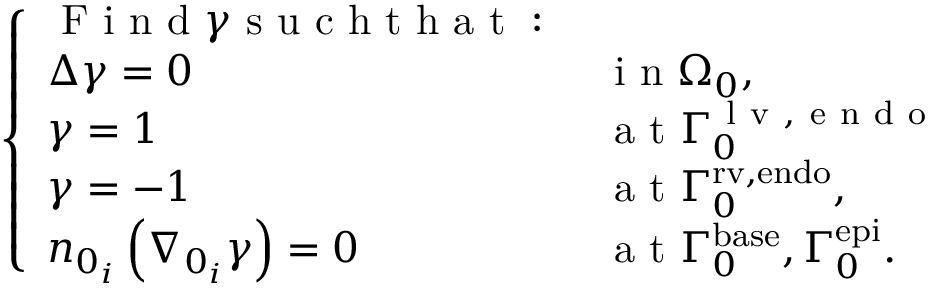Convert formula to latex. <formula><loc_0><loc_0><loc_500><loc_500>\left \{ \begin{array} { l l } { F i n d \gamma s u c h t h a t \colon } \\ { \Delta \gamma = 0 } & { i n { \Omega } _ { 0 } , } \\ { \gamma = 1 } & { a t { \Gamma } _ { 0 } ^ { l v , e n d o } } \\ { \gamma = - 1 } & { a t { \Gamma } _ { 0 } ^ { r v , e n d o } , } \\ { n _ { 0 _ { i } } \left ( \nabla _ { 0 _ { i } } \gamma \right ) = 0 } & { a t { \Gamma } _ { 0 } ^ { b a s e } , { \Gamma } _ { 0 } ^ { e p i } . } \end{array}</formula> 